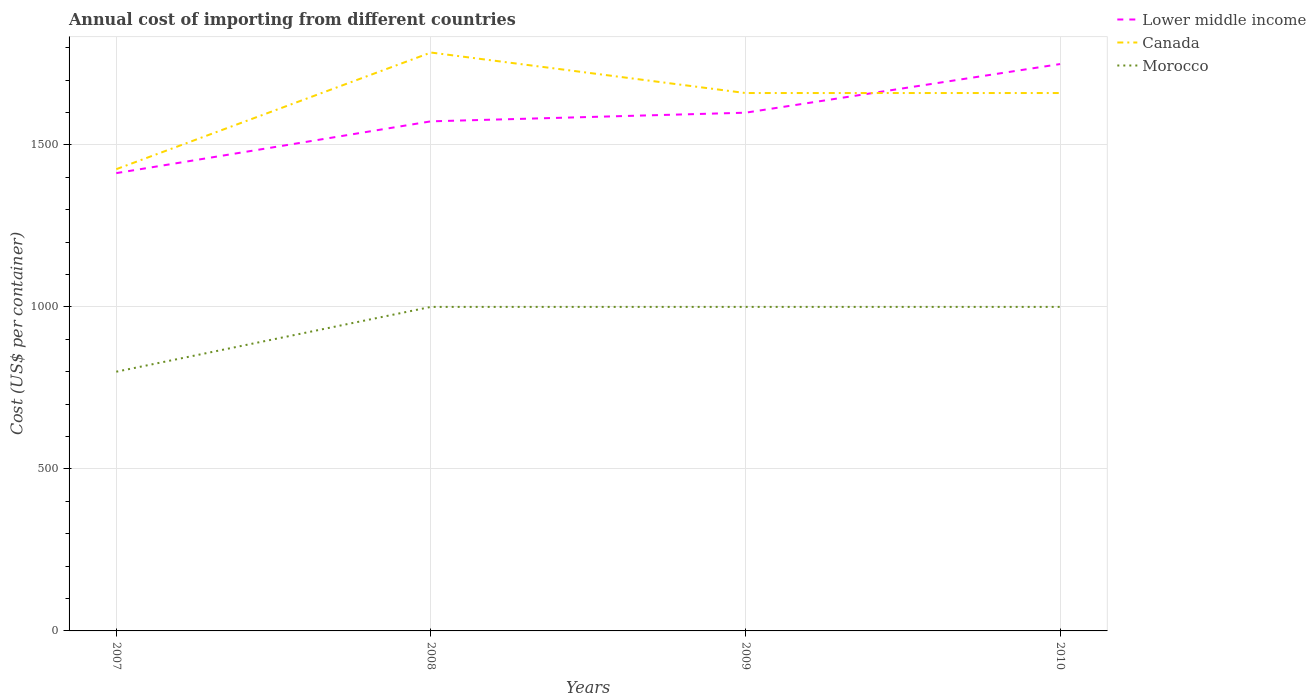Is the number of lines equal to the number of legend labels?
Your response must be concise. Yes. Across all years, what is the maximum total annual cost of importing in Canada?
Provide a succinct answer. 1425. What is the total total annual cost of importing in Morocco in the graph?
Provide a succinct answer. 0. What is the difference between the highest and the second highest total annual cost of importing in Morocco?
Make the answer very short. 200. What is the difference between the highest and the lowest total annual cost of importing in Lower middle income?
Your response must be concise. 2. Is the total annual cost of importing in Canada strictly greater than the total annual cost of importing in Morocco over the years?
Your answer should be compact. No. How many lines are there?
Your answer should be compact. 3. What is the difference between two consecutive major ticks on the Y-axis?
Your response must be concise. 500. Are the values on the major ticks of Y-axis written in scientific E-notation?
Offer a terse response. No. How many legend labels are there?
Your response must be concise. 3. How are the legend labels stacked?
Provide a succinct answer. Vertical. What is the title of the graph?
Provide a succinct answer. Annual cost of importing from different countries. What is the label or title of the Y-axis?
Give a very brief answer. Cost (US$ per container). What is the Cost (US$ per container) in Lower middle income in 2007?
Provide a succinct answer. 1412.82. What is the Cost (US$ per container) of Canada in 2007?
Keep it short and to the point. 1425. What is the Cost (US$ per container) in Morocco in 2007?
Offer a terse response. 800. What is the Cost (US$ per container) of Lower middle income in 2008?
Make the answer very short. 1572.65. What is the Cost (US$ per container) of Canada in 2008?
Offer a terse response. 1785. What is the Cost (US$ per container) of Lower middle income in 2009?
Offer a terse response. 1599.32. What is the Cost (US$ per container) in Canada in 2009?
Your answer should be compact. 1660. What is the Cost (US$ per container) in Morocco in 2009?
Your answer should be very brief. 1000. What is the Cost (US$ per container) in Lower middle income in 2010?
Your answer should be compact. 1749.42. What is the Cost (US$ per container) in Canada in 2010?
Give a very brief answer. 1660. Across all years, what is the maximum Cost (US$ per container) of Lower middle income?
Give a very brief answer. 1749.42. Across all years, what is the maximum Cost (US$ per container) in Canada?
Offer a very short reply. 1785. Across all years, what is the minimum Cost (US$ per container) of Lower middle income?
Provide a succinct answer. 1412.82. Across all years, what is the minimum Cost (US$ per container) in Canada?
Offer a terse response. 1425. Across all years, what is the minimum Cost (US$ per container) in Morocco?
Your answer should be compact. 800. What is the total Cost (US$ per container) of Lower middle income in the graph?
Offer a very short reply. 6334.21. What is the total Cost (US$ per container) of Canada in the graph?
Your answer should be compact. 6530. What is the total Cost (US$ per container) in Morocco in the graph?
Give a very brief answer. 3800. What is the difference between the Cost (US$ per container) in Lower middle income in 2007 and that in 2008?
Give a very brief answer. -159.84. What is the difference between the Cost (US$ per container) in Canada in 2007 and that in 2008?
Offer a very short reply. -360. What is the difference between the Cost (US$ per container) of Morocco in 2007 and that in 2008?
Give a very brief answer. -200. What is the difference between the Cost (US$ per container) of Lower middle income in 2007 and that in 2009?
Ensure brevity in your answer.  -186.5. What is the difference between the Cost (US$ per container) of Canada in 2007 and that in 2009?
Provide a short and direct response. -235. What is the difference between the Cost (US$ per container) of Morocco in 2007 and that in 2009?
Your answer should be very brief. -200. What is the difference between the Cost (US$ per container) of Lower middle income in 2007 and that in 2010?
Provide a succinct answer. -336.6. What is the difference between the Cost (US$ per container) in Canada in 2007 and that in 2010?
Give a very brief answer. -235. What is the difference between the Cost (US$ per container) of Morocco in 2007 and that in 2010?
Your answer should be compact. -200. What is the difference between the Cost (US$ per container) of Lower middle income in 2008 and that in 2009?
Your answer should be very brief. -26.67. What is the difference between the Cost (US$ per container) in Canada in 2008 and that in 2009?
Your answer should be compact. 125. What is the difference between the Cost (US$ per container) of Lower middle income in 2008 and that in 2010?
Make the answer very short. -176.77. What is the difference between the Cost (US$ per container) in Canada in 2008 and that in 2010?
Your response must be concise. 125. What is the difference between the Cost (US$ per container) of Morocco in 2008 and that in 2010?
Your answer should be compact. 0. What is the difference between the Cost (US$ per container) in Lower middle income in 2009 and that in 2010?
Provide a succinct answer. -150.1. What is the difference between the Cost (US$ per container) of Canada in 2009 and that in 2010?
Your answer should be compact. 0. What is the difference between the Cost (US$ per container) of Morocco in 2009 and that in 2010?
Keep it short and to the point. 0. What is the difference between the Cost (US$ per container) of Lower middle income in 2007 and the Cost (US$ per container) of Canada in 2008?
Give a very brief answer. -372.18. What is the difference between the Cost (US$ per container) in Lower middle income in 2007 and the Cost (US$ per container) in Morocco in 2008?
Keep it short and to the point. 412.82. What is the difference between the Cost (US$ per container) of Canada in 2007 and the Cost (US$ per container) of Morocco in 2008?
Offer a very short reply. 425. What is the difference between the Cost (US$ per container) of Lower middle income in 2007 and the Cost (US$ per container) of Canada in 2009?
Provide a succinct answer. -247.18. What is the difference between the Cost (US$ per container) in Lower middle income in 2007 and the Cost (US$ per container) in Morocco in 2009?
Give a very brief answer. 412.82. What is the difference between the Cost (US$ per container) in Canada in 2007 and the Cost (US$ per container) in Morocco in 2009?
Make the answer very short. 425. What is the difference between the Cost (US$ per container) in Lower middle income in 2007 and the Cost (US$ per container) in Canada in 2010?
Your answer should be compact. -247.18. What is the difference between the Cost (US$ per container) of Lower middle income in 2007 and the Cost (US$ per container) of Morocco in 2010?
Make the answer very short. 412.82. What is the difference between the Cost (US$ per container) of Canada in 2007 and the Cost (US$ per container) of Morocco in 2010?
Offer a very short reply. 425. What is the difference between the Cost (US$ per container) in Lower middle income in 2008 and the Cost (US$ per container) in Canada in 2009?
Make the answer very short. -87.35. What is the difference between the Cost (US$ per container) in Lower middle income in 2008 and the Cost (US$ per container) in Morocco in 2009?
Your answer should be very brief. 572.65. What is the difference between the Cost (US$ per container) in Canada in 2008 and the Cost (US$ per container) in Morocco in 2009?
Your answer should be very brief. 785. What is the difference between the Cost (US$ per container) in Lower middle income in 2008 and the Cost (US$ per container) in Canada in 2010?
Provide a short and direct response. -87.35. What is the difference between the Cost (US$ per container) of Lower middle income in 2008 and the Cost (US$ per container) of Morocco in 2010?
Give a very brief answer. 572.65. What is the difference between the Cost (US$ per container) of Canada in 2008 and the Cost (US$ per container) of Morocco in 2010?
Make the answer very short. 785. What is the difference between the Cost (US$ per container) in Lower middle income in 2009 and the Cost (US$ per container) in Canada in 2010?
Offer a very short reply. -60.68. What is the difference between the Cost (US$ per container) of Lower middle income in 2009 and the Cost (US$ per container) of Morocco in 2010?
Give a very brief answer. 599.32. What is the difference between the Cost (US$ per container) in Canada in 2009 and the Cost (US$ per container) in Morocco in 2010?
Provide a short and direct response. 660. What is the average Cost (US$ per container) in Lower middle income per year?
Give a very brief answer. 1583.55. What is the average Cost (US$ per container) of Canada per year?
Provide a short and direct response. 1632.5. What is the average Cost (US$ per container) of Morocco per year?
Make the answer very short. 950. In the year 2007, what is the difference between the Cost (US$ per container) in Lower middle income and Cost (US$ per container) in Canada?
Your answer should be compact. -12.18. In the year 2007, what is the difference between the Cost (US$ per container) of Lower middle income and Cost (US$ per container) of Morocco?
Ensure brevity in your answer.  612.82. In the year 2007, what is the difference between the Cost (US$ per container) of Canada and Cost (US$ per container) of Morocco?
Your answer should be very brief. 625. In the year 2008, what is the difference between the Cost (US$ per container) in Lower middle income and Cost (US$ per container) in Canada?
Ensure brevity in your answer.  -212.35. In the year 2008, what is the difference between the Cost (US$ per container) in Lower middle income and Cost (US$ per container) in Morocco?
Provide a succinct answer. 572.65. In the year 2008, what is the difference between the Cost (US$ per container) in Canada and Cost (US$ per container) in Morocco?
Your answer should be compact. 785. In the year 2009, what is the difference between the Cost (US$ per container) of Lower middle income and Cost (US$ per container) of Canada?
Your response must be concise. -60.68. In the year 2009, what is the difference between the Cost (US$ per container) of Lower middle income and Cost (US$ per container) of Morocco?
Make the answer very short. 599.32. In the year 2009, what is the difference between the Cost (US$ per container) in Canada and Cost (US$ per container) in Morocco?
Offer a very short reply. 660. In the year 2010, what is the difference between the Cost (US$ per container) in Lower middle income and Cost (US$ per container) in Canada?
Ensure brevity in your answer.  89.42. In the year 2010, what is the difference between the Cost (US$ per container) in Lower middle income and Cost (US$ per container) in Morocco?
Provide a succinct answer. 749.42. In the year 2010, what is the difference between the Cost (US$ per container) of Canada and Cost (US$ per container) of Morocco?
Ensure brevity in your answer.  660. What is the ratio of the Cost (US$ per container) of Lower middle income in 2007 to that in 2008?
Provide a short and direct response. 0.9. What is the ratio of the Cost (US$ per container) in Canada in 2007 to that in 2008?
Your response must be concise. 0.8. What is the ratio of the Cost (US$ per container) in Morocco in 2007 to that in 2008?
Offer a very short reply. 0.8. What is the ratio of the Cost (US$ per container) in Lower middle income in 2007 to that in 2009?
Give a very brief answer. 0.88. What is the ratio of the Cost (US$ per container) in Canada in 2007 to that in 2009?
Offer a very short reply. 0.86. What is the ratio of the Cost (US$ per container) in Morocco in 2007 to that in 2009?
Your answer should be compact. 0.8. What is the ratio of the Cost (US$ per container) in Lower middle income in 2007 to that in 2010?
Ensure brevity in your answer.  0.81. What is the ratio of the Cost (US$ per container) of Canada in 2007 to that in 2010?
Your answer should be very brief. 0.86. What is the ratio of the Cost (US$ per container) in Morocco in 2007 to that in 2010?
Ensure brevity in your answer.  0.8. What is the ratio of the Cost (US$ per container) in Lower middle income in 2008 to that in 2009?
Your response must be concise. 0.98. What is the ratio of the Cost (US$ per container) of Canada in 2008 to that in 2009?
Keep it short and to the point. 1.08. What is the ratio of the Cost (US$ per container) in Lower middle income in 2008 to that in 2010?
Ensure brevity in your answer.  0.9. What is the ratio of the Cost (US$ per container) of Canada in 2008 to that in 2010?
Your response must be concise. 1.08. What is the ratio of the Cost (US$ per container) of Lower middle income in 2009 to that in 2010?
Keep it short and to the point. 0.91. What is the ratio of the Cost (US$ per container) in Canada in 2009 to that in 2010?
Your response must be concise. 1. What is the difference between the highest and the second highest Cost (US$ per container) of Lower middle income?
Offer a very short reply. 150.1. What is the difference between the highest and the second highest Cost (US$ per container) of Canada?
Your response must be concise. 125. What is the difference between the highest and the lowest Cost (US$ per container) in Lower middle income?
Provide a succinct answer. 336.6. What is the difference between the highest and the lowest Cost (US$ per container) of Canada?
Provide a short and direct response. 360. 